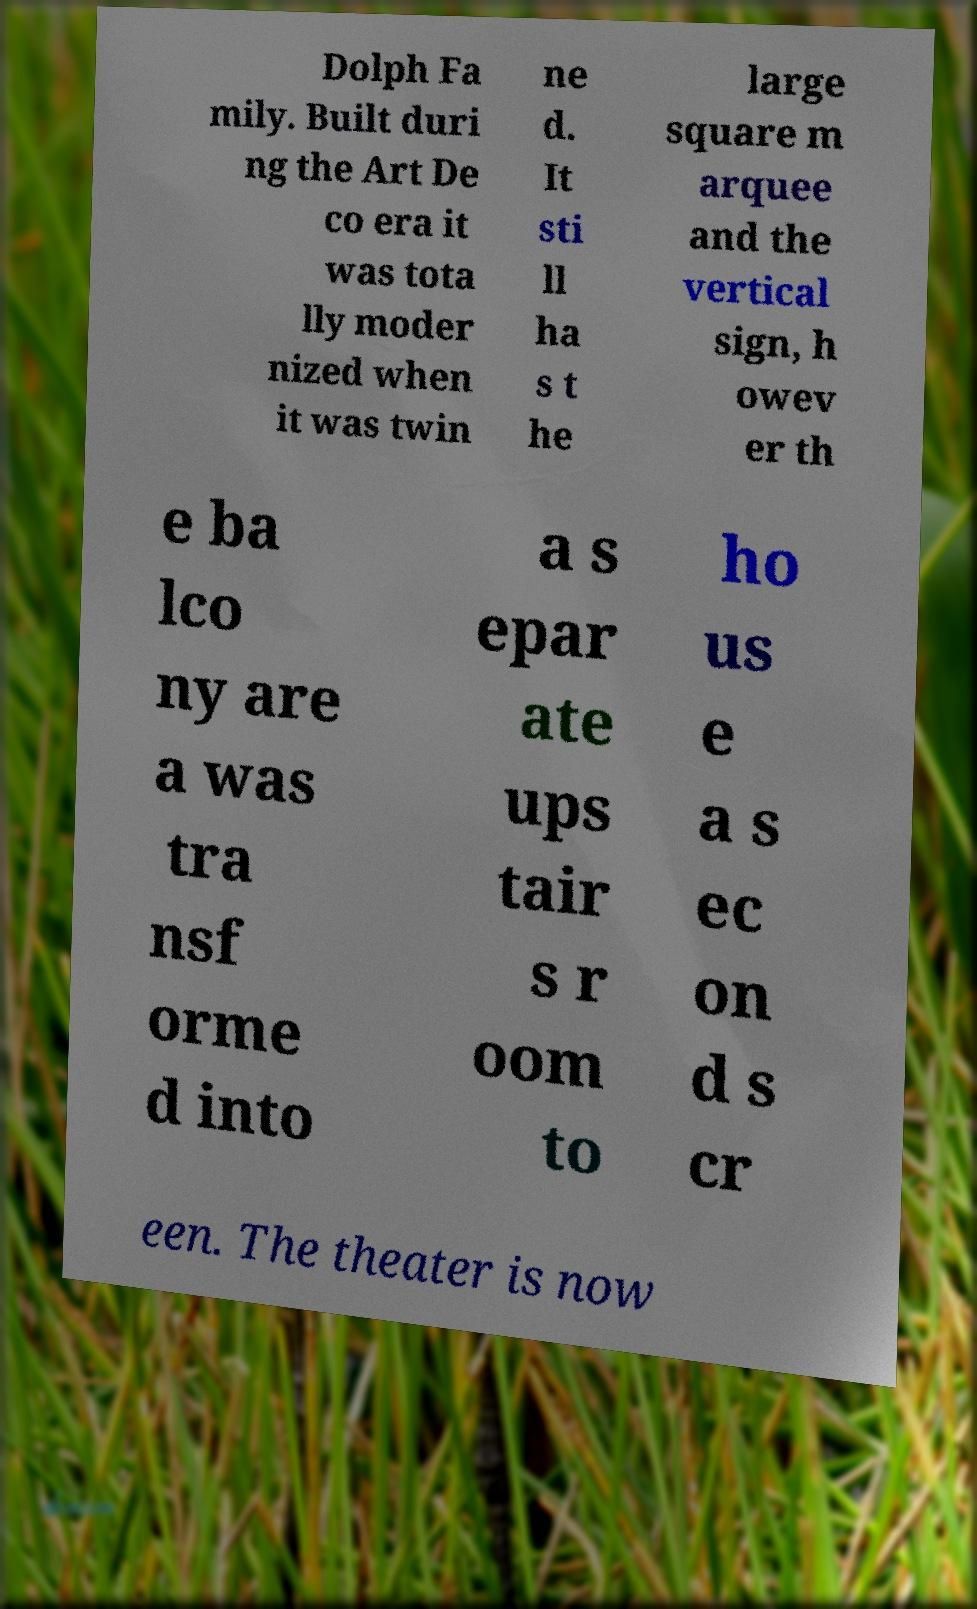Could you assist in decoding the text presented in this image and type it out clearly? Dolph Fa mily. Built duri ng the Art De co era it was tota lly moder nized when it was twin ne d. It sti ll ha s t he large square m arquee and the vertical sign, h owev er th e ba lco ny are a was tra nsf orme d into a s epar ate ups tair s r oom to ho us e a s ec on d s cr een. The theater is now 